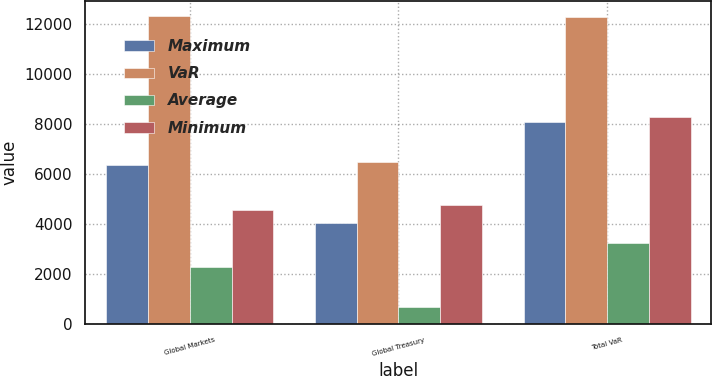Convert chart to OTSL. <chart><loc_0><loc_0><loc_500><loc_500><stacked_bar_chart><ecel><fcel>Global Markets<fcel>Global Treasury<fcel>Total VaR<nl><fcel>Maximum<fcel>6365<fcel>4027<fcel>8100<nl><fcel>VaR<fcel>12327<fcel>6467<fcel>12278<nl><fcel>Average<fcel>2273<fcel>683<fcel>3244<nl><fcel>Minimum<fcel>4566<fcel>4759<fcel>8281<nl></chart> 